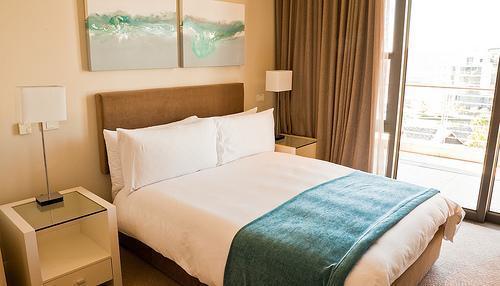How many pillows are on the bed?
Give a very brief answer. 4. How many pictures are above the headboard?
Give a very brief answer. 2. How many lamps are shown?
Give a very brief answer. 2. How many drawers are pictured?
Give a very brief answer. 1. How many pillows?
Give a very brief answer. 4. How many paintings?
Give a very brief answer. 2. How many lamps are there?
Give a very brief answer. 2. 